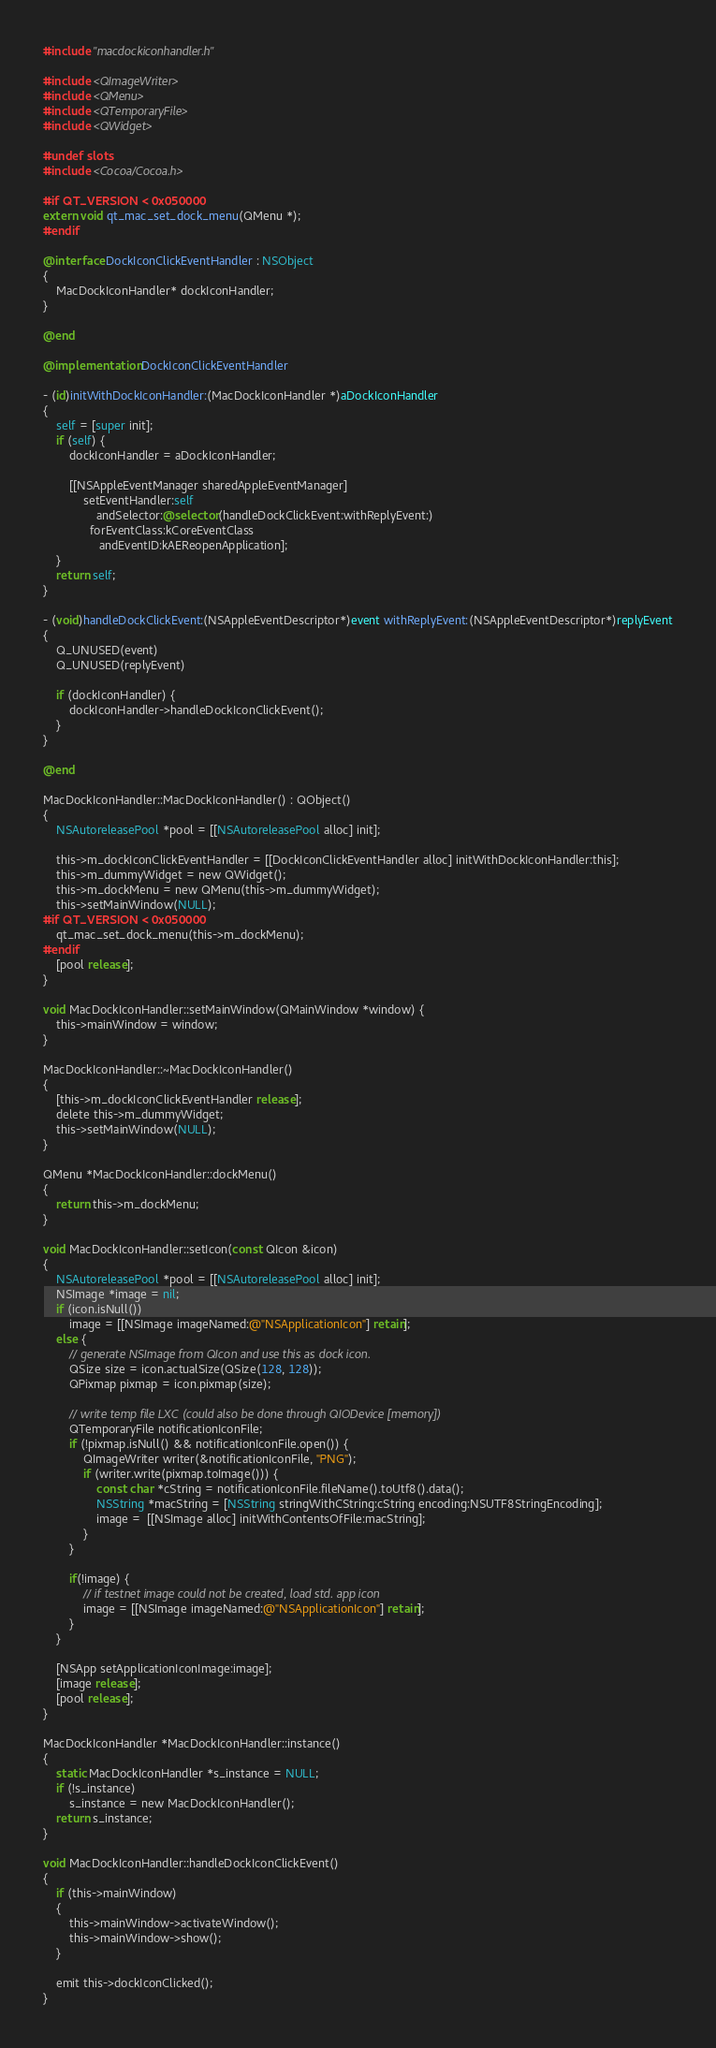Convert code to text. <code><loc_0><loc_0><loc_500><loc_500><_ObjectiveC_>#include "macdockiconhandler.h"

#include <QImageWriter>
#include <QMenu>
#include <QTemporaryFile>
#include <QWidget>

#undef slots
#include <Cocoa/Cocoa.h>

#if QT_VERSION < 0x050000
extern void qt_mac_set_dock_menu(QMenu *);
#endif

@interface DockIconClickEventHandler : NSObject
{
    MacDockIconHandler* dockIconHandler;
}

@end

@implementation DockIconClickEventHandler

- (id)initWithDockIconHandler:(MacDockIconHandler *)aDockIconHandler
{
    self = [super init];
    if (self) {
        dockIconHandler = aDockIconHandler;

        [[NSAppleEventManager sharedAppleEventManager]
            setEventHandler:self
                andSelector:@selector(handleDockClickEvent:withReplyEvent:)
              forEventClass:kCoreEventClass
                 andEventID:kAEReopenApplication];
    }
    return self;
}

- (void)handleDockClickEvent:(NSAppleEventDescriptor*)event withReplyEvent:(NSAppleEventDescriptor*)replyEvent
{
    Q_UNUSED(event)
    Q_UNUSED(replyEvent)

    if (dockIconHandler) {
        dockIconHandler->handleDockIconClickEvent();
    }
}

@end

MacDockIconHandler::MacDockIconHandler() : QObject()
{
    NSAutoreleasePool *pool = [[NSAutoreleasePool alloc] init];

    this->m_dockIconClickEventHandler = [[DockIconClickEventHandler alloc] initWithDockIconHandler:this];
    this->m_dummyWidget = new QWidget();
    this->m_dockMenu = new QMenu(this->m_dummyWidget);
    this->setMainWindow(NULL);
#if QT_VERSION < 0x050000
    qt_mac_set_dock_menu(this->m_dockMenu);
#endif
    [pool release];
}

void MacDockIconHandler::setMainWindow(QMainWindow *window) {
    this->mainWindow = window;
}

MacDockIconHandler::~MacDockIconHandler()
{
    [this->m_dockIconClickEventHandler release];
    delete this->m_dummyWidget;
    this->setMainWindow(NULL);
}

QMenu *MacDockIconHandler::dockMenu()
{
    return this->m_dockMenu;
}

void MacDockIconHandler::setIcon(const QIcon &icon)
{
    NSAutoreleasePool *pool = [[NSAutoreleasePool alloc] init];
    NSImage *image = nil;
    if (icon.isNull())
        image = [[NSImage imageNamed:@"NSApplicationIcon"] retain];
    else {
        // generate NSImage from QIcon and use this as dock icon.
        QSize size = icon.actualSize(QSize(128, 128));
        QPixmap pixmap = icon.pixmap(size);

        // write temp file LXC (could also be done through QIODevice [memory])
        QTemporaryFile notificationIconFile;
        if (!pixmap.isNull() && notificationIconFile.open()) {
            QImageWriter writer(&notificationIconFile, "PNG");
            if (writer.write(pixmap.toImage())) {
                const char *cString = notificationIconFile.fileName().toUtf8().data();
                NSString *macString = [NSString stringWithCString:cString encoding:NSUTF8StringEncoding];
                image =  [[NSImage alloc] initWithContentsOfFile:macString];
            }
        }

        if(!image) {
            // if testnet image could not be created, load std. app icon
            image = [[NSImage imageNamed:@"NSApplicationIcon"] retain];
        }
    }

    [NSApp setApplicationIconImage:image];
    [image release];
    [pool release];
}

MacDockIconHandler *MacDockIconHandler::instance()
{
    static MacDockIconHandler *s_instance = NULL;
    if (!s_instance)
        s_instance = new MacDockIconHandler();
    return s_instance;
}

void MacDockIconHandler::handleDockIconClickEvent()
{
    if (this->mainWindow)
    {
        this->mainWindow->activateWindow();
        this->mainWindow->show();
    }

    emit this->dockIconClicked();
}
</code> 